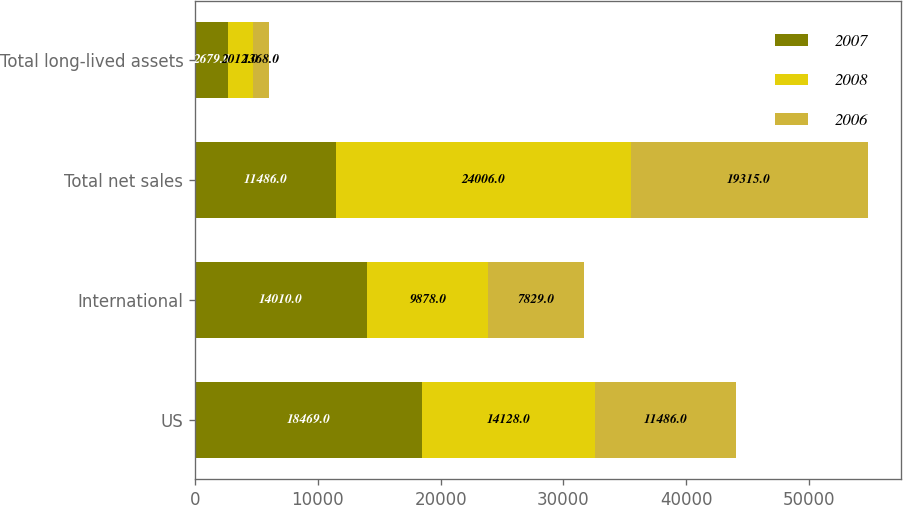<chart> <loc_0><loc_0><loc_500><loc_500><stacked_bar_chart><ecel><fcel>US<fcel>International<fcel>Total net sales<fcel>Total long-lived assets<nl><fcel>2007<fcel>18469<fcel>14010<fcel>11486<fcel>2679<nl><fcel>2008<fcel>14128<fcel>9878<fcel>24006<fcel>2012<nl><fcel>2006<fcel>11486<fcel>7829<fcel>19315<fcel>1368<nl></chart> 